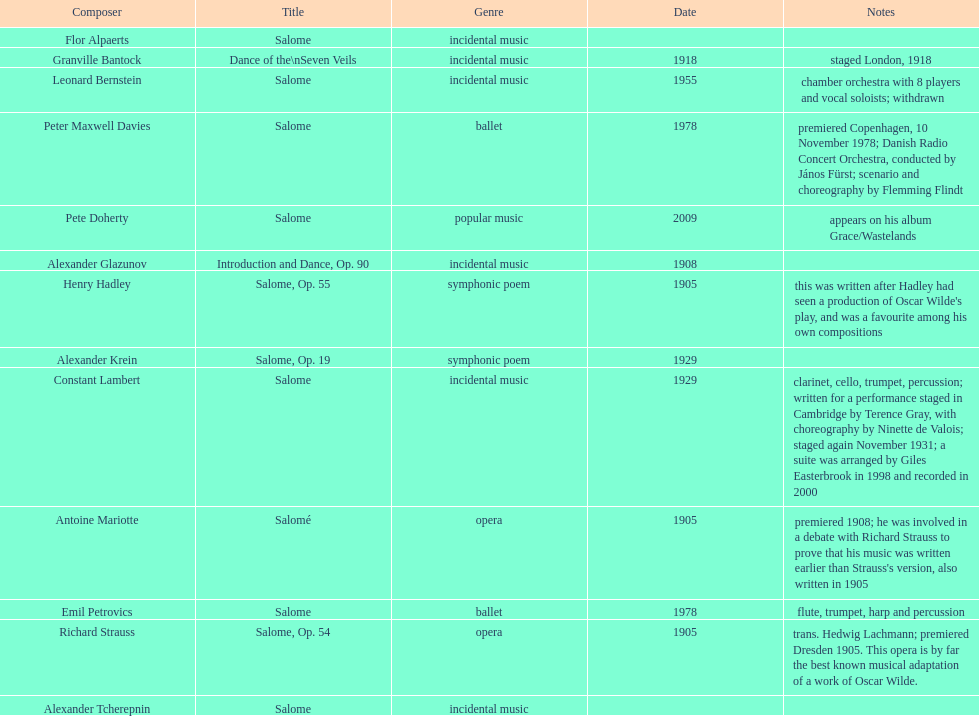Which composer created their title after 2001? Pete Doherty. 